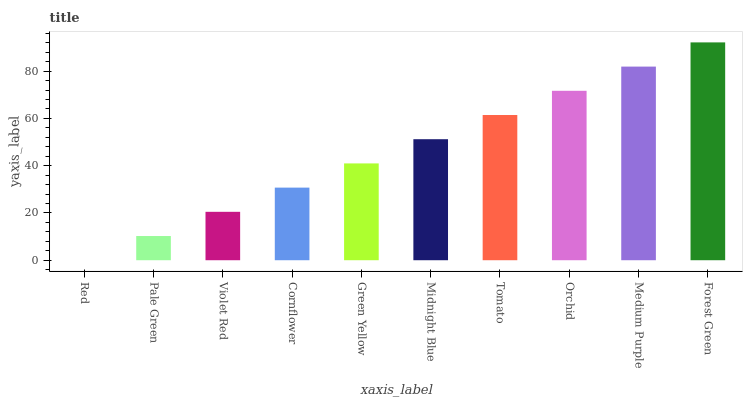Is Red the minimum?
Answer yes or no. Yes. Is Forest Green the maximum?
Answer yes or no. Yes. Is Pale Green the minimum?
Answer yes or no. No. Is Pale Green the maximum?
Answer yes or no. No. Is Pale Green greater than Red?
Answer yes or no. Yes. Is Red less than Pale Green?
Answer yes or no. Yes. Is Red greater than Pale Green?
Answer yes or no. No. Is Pale Green less than Red?
Answer yes or no. No. Is Midnight Blue the high median?
Answer yes or no. Yes. Is Green Yellow the low median?
Answer yes or no. Yes. Is Medium Purple the high median?
Answer yes or no. No. Is Midnight Blue the low median?
Answer yes or no. No. 